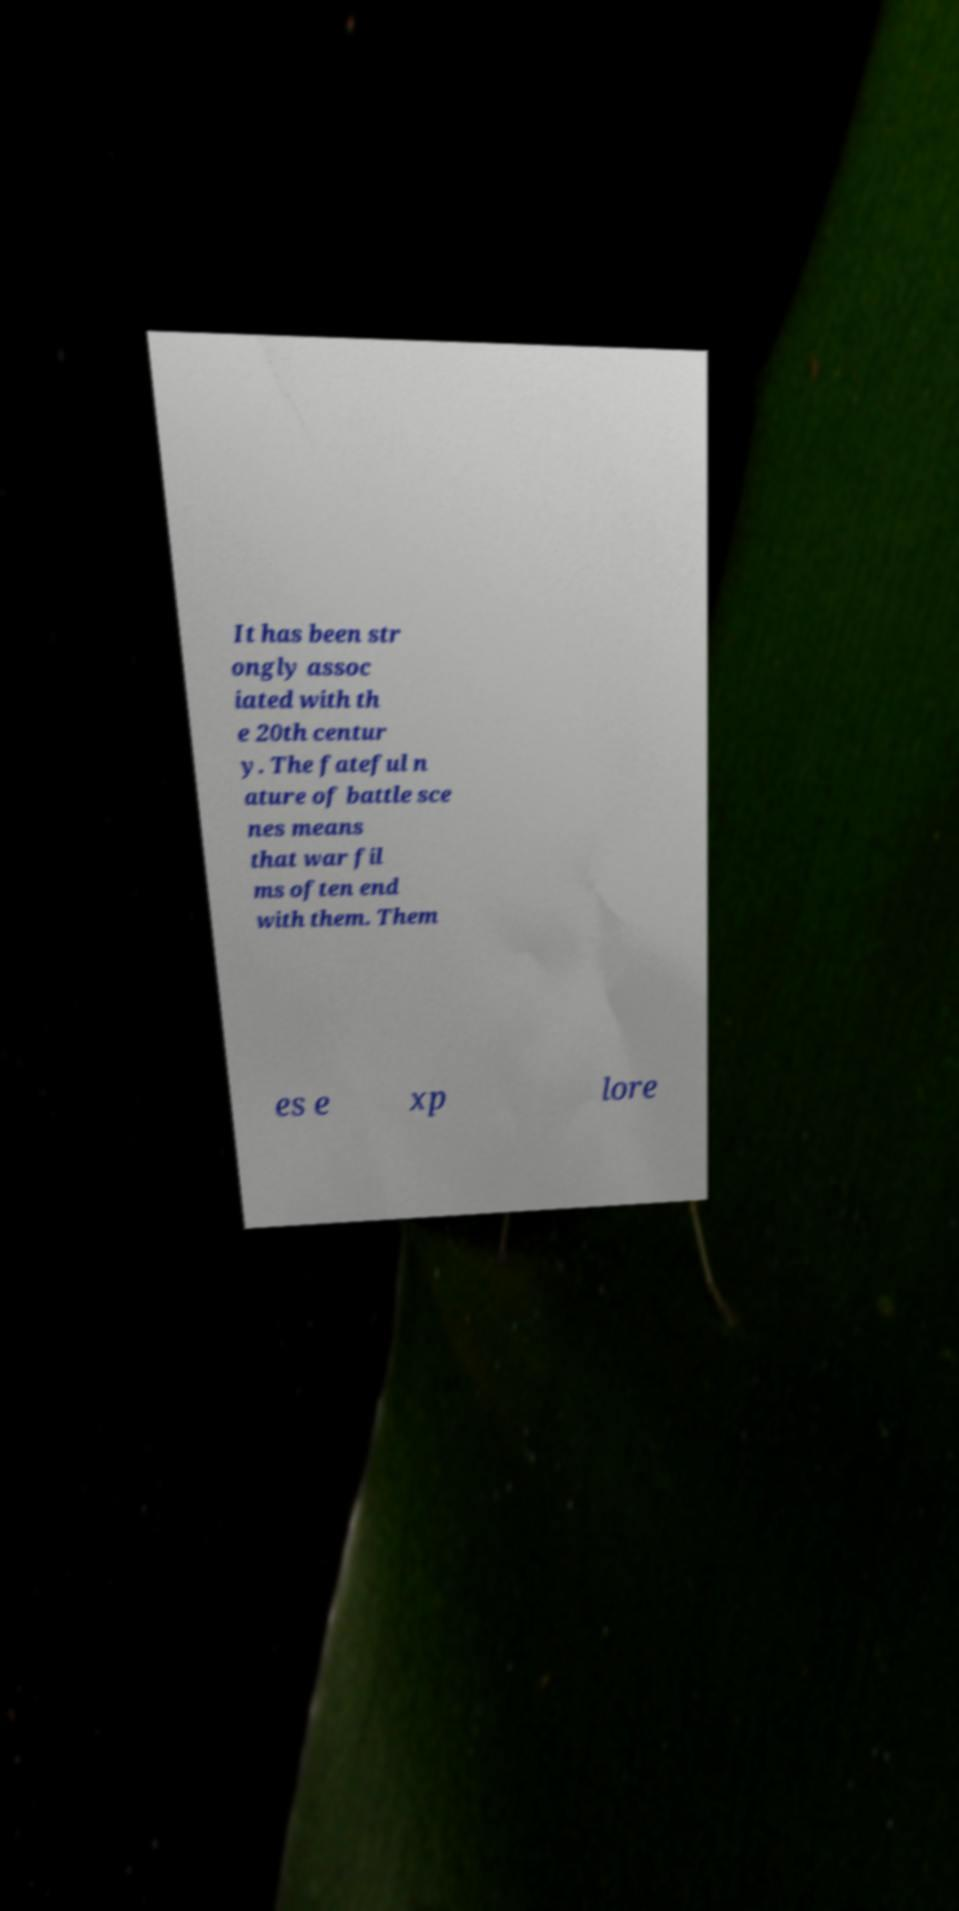Can you accurately transcribe the text from the provided image for me? It has been str ongly assoc iated with th e 20th centur y. The fateful n ature of battle sce nes means that war fil ms often end with them. Them es e xp lore 